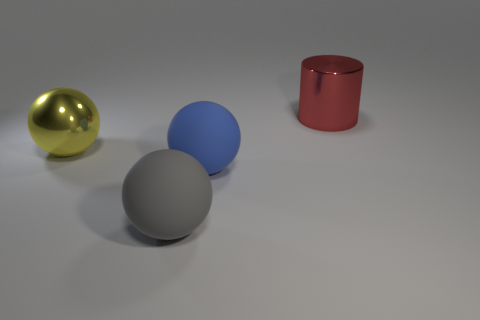Add 4 big green objects. How many objects exist? 8 Subtract all cylinders. How many objects are left? 3 Subtract all big metallic things. Subtract all large cyan shiny things. How many objects are left? 2 Add 1 gray balls. How many gray balls are left? 2 Add 4 shiny cylinders. How many shiny cylinders exist? 5 Subtract 0 gray cubes. How many objects are left? 4 